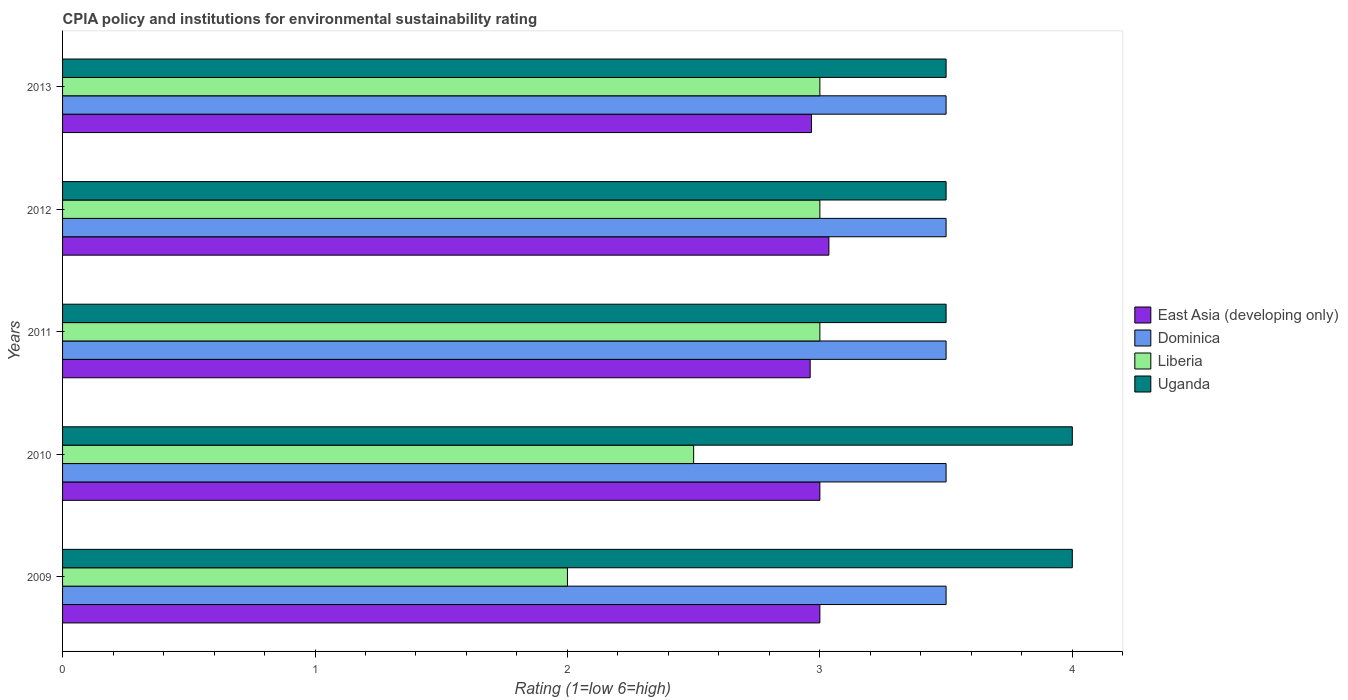How many different coloured bars are there?
Make the answer very short. 4. How many bars are there on the 1st tick from the bottom?
Your answer should be compact. 4. What is the label of the 1st group of bars from the top?
Your response must be concise. 2013. In how many cases, is the number of bars for a given year not equal to the number of legend labels?
Make the answer very short. 0. In which year was the CPIA rating in East Asia (developing only) maximum?
Offer a terse response. 2012. In which year was the CPIA rating in Uganda minimum?
Your answer should be compact. 2011. What is the total CPIA rating in Dominica in the graph?
Offer a terse response. 17.5. What is the difference between the CPIA rating in East Asia (developing only) in 2009 and that in 2011?
Offer a terse response. 0.04. What is the difference between the CPIA rating in Uganda in 2011 and the CPIA rating in Liberia in 2012?
Provide a short and direct response. 0.5. What is the average CPIA rating in East Asia (developing only) per year?
Provide a short and direct response. 2.99. In the year 2011, what is the difference between the CPIA rating in East Asia (developing only) and CPIA rating in Dominica?
Provide a succinct answer. -0.54. What is the ratio of the CPIA rating in Liberia in 2012 to that in 2013?
Provide a succinct answer. 1. Is the CPIA rating in Dominica in 2011 less than that in 2012?
Offer a very short reply. No. What is the difference between the highest and the second highest CPIA rating in East Asia (developing only)?
Your answer should be compact. 0.04. In how many years, is the CPIA rating in East Asia (developing only) greater than the average CPIA rating in East Asia (developing only) taken over all years?
Give a very brief answer. 3. Is the sum of the CPIA rating in East Asia (developing only) in 2010 and 2011 greater than the maximum CPIA rating in Uganda across all years?
Offer a very short reply. Yes. What does the 1st bar from the top in 2011 represents?
Provide a short and direct response. Uganda. What does the 2nd bar from the bottom in 2010 represents?
Your answer should be compact. Dominica. How many bars are there?
Ensure brevity in your answer.  20. Are all the bars in the graph horizontal?
Your answer should be very brief. Yes. How many years are there in the graph?
Offer a very short reply. 5. What is the difference between two consecutive major ticks on the X-axis?
Keep it short and to the point. 1. Are the values on the major ticks of X-axis written in scientific E-notation?
Give a very brief answer. No. Does the graph contain any zero values?
Make the answer very short. No. How many legend labels are there?
Provide a short and direct response. 4. What is the title of the graph?
Your response must be concise. CPIA policy and institutions for environmental sustainability rating. Does "Oman" appear as one of the legend labels in the graph?
Your answer should be compact. No. What is the label or title of the X-axis?
Offer a terse response. Rating (1=low 6=high). What is the Rating (1=low 6=high) in East Asia (developing only) in 2009?
Keep it short and to the point. 3. What is the Rating (1=low 6=high) in Dominica in 2009?
Ensure brevity in your answer.  3.5. What is the Rating (1=low 6=high) of Uganda in 2010?
Offer a terse response. 4. What is the Rating (1=low 6=high) of East Asia (developing only) in 2011?
Provide a succinct answer. 2.96. What is the Rating (1=low 6=high) in Liberia in 2011?
Your response must be concise. 3. What is the Rating (1=low 6=high) in East Asia (developing only) in 2012?
Your response must be concise. 3.04. What is the Rating (1=low 6=high) in Dominica in 2012?
Offer a very short reply. 3.5. What is the Rating (1=low 6=high) of Uganda in 2012?
Ensure brevity in your answer.  3.5. What is the Rating (1=low 6=high) of East Asia (developing only) in 2013?
Your answer should be compact. 2.97. What is the Rating (1=low 6=high) of Dominica in 2013?
Offer a terse response. 3.5. What is the Rating (1=low 6=high) of Uganda in 2013?
Your answer should be very brief. 3.5. Across all years, what is the maximum Rating (1=low 6=high) in East Asia (developing only)?
Keep it short and to the point. 3.04. Across all years, what is the maximum Rating (1=low 6=high) of Uganda?
Offer a terse response. 4. Across all years, what is the minimum Rating (1=low 6=high) in East Asia (developing only)?
Offer a very short reply. 2.96. Across all years, what is the minimum Rating (1=low 6=high) of Liberia?
Your answer should be very brief. 2. Across all years, what is the minimum Rating (1=low 6=high) of Uganda?
Make the answer very short. 3.5. What is the total Rating (1=low 6=high) in East Asia (developing only) in the graph?
Your answer should be compact. 14.96. What is the total Rating (1=low 6=high) in Dominica in the graph?
Provide a short and direct response. 17.5. What is the total Rating (1=low 6=high) in Liberia in the graph?
Offer a terse response. 13.5. What is the total Rating (1=low 6=high) in Uganda in the graph?
Your answer should be compact. 18.5. What is the difference between the Rating (1=low 6=high) of East Asia (developing only) in 2009 and that in 2010?
Provide a short and direct response. 0. What is the difference between the Rating (1=low 6=high) of Dominica in 2009 and that in 2010?
Offer a very short reply. 0. What is the difference between the Rating (1=low 6=high) of Liberia in 2009 and that in 2010?
Provide a short and direct response. -0.5. What is the difference between the Rating (1=low 6=high) in Uganda in 2009 and that in 2010?
Provide a short and direct response. 0. What is the difference between the Rating (1=low 6=high) in East Asia (developing only) in 2009 and that in 2011?
Your answer should be compact. 0.04. What is the difference between the Rating (1=low 6=high) in Liberia in 2009 and that in 2011?
Your answer should be very brief. -1. What is the difference between the Rating (1=low 6=high) of East Asia (developing only) in 2009 and that in 2012?
Offer a terse response. -0.04. What is the difference between the Rating (1=low 6=high) of Dominica in 2009 and that in 2012?
Keep it short and to the point. 0. What is the difference between the Rating (1=low 6=high) in Uganda in 2009 and that in 2012?
Provide a short and direct response. 0.5. What is the difference between the Rating (1=low 6=high) in East Asia (developing only) in 2009 and that in 2013?
Ensure brevity in your answer.  0.03. What is the difference between the Rating (1=low 6=high) in Liberia in 2009 and that in 2013?
Your response must be concise. -1. What is the difference between the Rating (1=low 6=high) of Uganda in 2009 and that in 2013?
Keep it short and to the point. 0.5. What is the difference between the Rating (1=low 6=high) of East Asia (developing only) in 2010 and that in 2011?
Your answer should be compact. 0.04. What is the difference between the Rating (1=low 6=high) in East Asia (developing only) in 2010 and that in 2012?
Give a very brief answer. -0.04. What is the difference between the Rating (1=low 6=high) in East Asia (developing only) in 2010 and that in 2013?
Offer a terse response. 0.03. What is the difference between the Rating (1=low 6=high) of Dominica in 2010 and that in 2013?
Ensure brevity in your answer.  0. What is the difference between the Rating (1=low 6=high) of East Asia (developing only) in 2011 and that in 2012?
Ensure brevity in your answer.  -0.07. What is the difference between the Rating (1=low 6=high) in Dominica in 2011 and that in 2012?
Offer a terse response. 0. What is the difference between the Rating (1=low 6=high) of Uganda in 2011 and that in 2012?
Ensure brevity in your answer.  0. What is the difference between the Rating (1=low 6=high) of East Asia (developing only) in 2011 and that in 2013?
Offer a very short reply. -0.01. What is the difference between the Rating (1=low 6=high) in Uganda in 2011 and that in 2013?
Offer a terse response. 0. What is the difference between the Rating (1=low 6=high) of East Asia (developing only) in 2012 and that in 2013?
Your answer should be compact. 0.07. What is the difference between the Rating (1=low 6=high) in Dominica in 2012 and that in 2013?
Offer a very short reply. 0. What is the difference between the Rating (1=low 6=high) in Liberia in 2012 and that in 2013?
Keep it short and to the point. 0. What is the difference between the Rating (1=low 6=high) in Uganda in 2012 and that in 2013?
Your answer should be compact. 0. What is the difference between the Rating (1=low 6=high) of East Asia (developing only) in 2009 and the Rating (1=low 6=high) of Uganda in 2010?
Keep it short and to the point. -1. What is the difference between the Rating (1=low 6=high) in East Asia (developing only) in 2009 and the Rating (1=low 6=high) in Liberia in 2011?
Your answer should be very brief. 0. What is the difference between the Rating (1=low 6=high) of East Asia (developing only) in 2009 and the Rating (1=low 6=high) of Uganda in 2011?
Provide a short and direct response. -0.5. What is the difference between the Rating (1=low 6=high) in Dominica in 2009 and the Rating (1=low 6=high) in Liberia in 2011?
Your answer should be compact. 0.5. What is the difference between the Rating (1=low 6=high) of Dominica in 2009 and the Rating (1=low 6=high) of Uganda in 2011?
Give a very brief answer. 0. What is the difference between the Rating (1=low 6=high) in Liberia in 2009 and the Rating (1=low 6=high) in Uganda in 2011?
Your answer should be very brief. -1.5. What is the difference between the Rating (1=low 6=high) of East Asia (developing only) in 2009 and the Rating (1=low 6=high) of Dominica in 2012?
Provide a short and direct response. -0.5. What is the difference between the Rating (1=low 6=high) in East Asia (developing only) in 2009 and the Rating (1=low 6=high) in Liberia in 2012?
Make the answer very short. 0. What is the difference between the Rating (1=low 6=high) in East Asia (developing only) in 2009 and the Rating (1=low 6=high) in Dominica in 2013?
Your answer should be very brief. -0.5. What is the difference between the Rating (1=low 6=high) in East Asia (developing only) in 2009 and the Rating (1=low 6=high) in Liberia in 2013?
Offer a very short reply. 0. What is the difference between the Rating (1=low 6=high) of East Asia (developing only) in 2009 and the Rating (1=low 6=high) of Uganda in 2013?
Make the answer very short. -0.5. What is the difference between the Rating (1=low 6=high) in Dominica in 2009 and the Rating (1=low 6=high) in Uganda in 2013?
Provide a succinct answer. 0. What is the difference between the Rating (1=low 6=high) in East Asia (developing only) in 2010 and the Rating (1=low 6=high) in Dominica in 2011?
Provide a succinct answer. -0.5. What is the difference between the Rating (1=low 6=high) of East Asia (developing only) in 2010 and the Rating (1=low 6=high) of Liberia in 2011?
Make the answer very short. 0. What is the difference between the Rating (1=low 6=high) of East Asia (developing only) in 2010 and the Rating (1=low 6=high) of Uganda in 2011?
Your answer should be compact. -0.5. What is the difference between the Rating (1=low 6=high) in Dominica in 2010 and the Rating (1=low 6=high) in Liberia in 2011?
Provide a short and direct response. 0.5. What is the difference between the Rating (1=low 6=high) in Dominica in 2010 and the Rating (1=low 6=high) in Uganda in 2011?
Give a very brief answer. 0. What is the difference between the Rating (1=low 6=high) in East Asia (developing only) in 2010 and the Rating (1=low 6=high) in Dominica in 2012?
Ensure brevity in your answer.  -0.5. What is the difference between the Rating (1=low 6=high) in East Asia (developing only) in 2010 and the Rating (1=low 6=high) in Liberia in 2012?
Keep it short and to the point. 0. What is the difference between the Rating (1=low 6=high) of East Asia (developing only) in 2010 and the Rating (1=low 6=high) of Uganda in 2012?
Provide a short and direct response. -0.5. What is the difference between the Rating (1=low 6=high) in Dominica in 2010 and the Rating (1=low 6=high) in Liberia in 2012?
Keep it short and to the point. 0.5. What is the difference between the Rating (1=low 6=high) of Dominica in 2010 and the Rating (1=low 6=high) of Uganda in 2012?
Provide a succinct answer. 0. What is the difference between the Rating (1=low 6=high) of Liberia in 2010 and the Rating (1=low 6=high) of Uganda in 2012?
Offer a very short reply. -1. What is the difference between the Rating (1=low 6=high) in East Asia (developing only) in 2010 and the Rating (1=low 6=high) in Dominica in 2013?
Provide a short and direct response. -0.5. What is the difference between the Rating (1=low 6=high) of East Asia (developing only) in 2010 and the Rating (1=low 6=high) of Liberia in 2013?
Offer a terse response. 0. What is the difference between the Rating (1=low 6=high) of East Asia (developing only) in 2010 and the Rating (1=low 6=high) of Uganda in 2013?
Offer a terse response. -0.5. What is the difference between the Rating (1=low 6=high) in East Asia (developing only) in 2011 and the Rating (1=low 6=high) in Dominica in 2012?
Provide a short and direct response. -0.54. What is the difference between the Rating (1=low 6=high) in East Asia (developing only) in 2011 and the Rating (1=low 6=high) in Liberia in 2012?
Make the answer very short. -0.04. What is the difference between the Rating (1=low 6=high) in East Asia (developing only) in 2011 and the Rating (1=low 6=high) in Uganda in 2012?
Offer a terse response. -0.54. What is the difference between the Rating (1=low 6=high) in Dominica in 2011 and the Rating (1=low 6=high) in Liberia in 2012?
Make the answer very short. 0.5. What is the difference between the Rating (1=low 6=high) in East Asia (developing only) in 2011 and the Rating (1=low 6=high) in Dominica in 2013?
Your answer should be very brief. -0.54. What is the difference between the Rating (1=low 6=high) in East Asia (developing only) in 2011 and the Rating (1=low 6=high) in Liberia in 2013?
Ensure brevity in your answer.  -0.04. What is the difference between the Rating (1=low 6=high) in East Asia (developing only) in 2011 and the Rating (1=low 6=high) in Uganda in 2013?
Offer a terse response. -0.54. What is the difference between the Rating (1=low 6=high) in Dominica in 2011 and the Rating (1=low 6=high) in Uganda in 2013?
Give a very brief answer. 0. What is the difference between the Rating (1=low 6=high) in East Asia (developing only) in 2012 and the Rating (1=low 6=high) in Dominica in 2013?
Provide a short and direct response. -0.46. What is the difference between the Rating (1=low 6=high) in East Asia (developing only) in 2012 and the Rating (1=low 6=high) in Liberia in 2013?
Provide a short and direct response. 0.04. What is the difference between the Rating (1=low 6=high) of East Asia (developing only) in 2012 and the Rating (1=low 6=high) of Uganda in 2013?
Offer a terse response. -0.46. What is the difference between the Rating (1=low 6=high) in Dominica in 2012 and the Rating (1=low 6=high) in Uganda in 2013?
Offer a very short reply. 0. What is the difference between the Rating (1=low 6=high) of Liberia in 2012 and the Rating (1=low 6=high) of Uganda in 2013?
Your response must be concise. -0.5. What is the average Rating (1=low 6=high) in East Asia (developing only) per year?
Your response must be concise. 2.99. What is the average Rating (1=low 6=high) of Dominica per year?
Keep it short and to the point. 3.5. What is the average Rating (1=low 6=high) of Liberia per year?
Your response must be concise. 2.7. In the year 2009, what is the difference between the Rating (1=low 6=high) of East Asia (developing only) and Rating (1=low 6=high) of Dominica?
Your answer should be compact. -0.5. In the year 2009, what is the difference between the Rating (1=low 6=high) of East Asia (developing only) and Rating (1=low 6=high) of Liberia?
Provide a short and direct response. 1. In the year 2009, what is the difference between the Rating (1=low 6=high) of Dominica and Rating (1=low 6=high) of Liberia?
Your answer should be very brief. 1.5. In the year 2009, what is the difference between the Rating (1=low 6=high) in Liberia and Rating (1=low 6=high) in Uganda?
Your answer should be very brief. -2. In the year 2010, what is the difference between the Rating (1=low 6=high) of East Asia (developing only) and Rating (1=low 6=high) of Uganda?
Give a very brief answer. -1. In the year 2011, what is the difference between the Rating (1=low 6=high) of East Asia (developing only) and Rating (1=low 6=high) of Dominica?
Provide a succinct answer. -0.54. In the year 2011, what is the difference between the Rating (1=low 6=high) in East Asia (developing only) and Rating (1=low 6=high) in Liberia?
Your response must be concise. -0.04. In the year 2011, what is the difference between the Rating (1=low 6=high) in East Asia (developing only) and Rating (1=low 6=high) in Uganda?
Your response must be concise. -0.54. In the year 2011, what is the difference between the Rating (1=low 6=high) in Liberia and Rating (1=low 6=high) in Uganda?
Your response must be concise. -0.5. In the year 2012, what is the difference between the Rating (1=low 6=high) of East Asia (developing only) and Rating (1=low 6=high) of Dominica?
Keep it short and to the point. -0.46. In the year 2012, what is the difference between the Rating (1=low 6=high) of East Asia (developing only) and Rating (1=low 6=high) of Liberia?
Make the answer very short. 0.04. In the year 2012, what is the difference between the Rating (1=low 6=high) of East Asia (developing only) and Rating (1=low 6=high) of Uganda?
Make the answer very short. -0.46. In the year 2012, what is the difference between the Rating (1=low 6=high) of Dominica and Rating (1=low 6=high) of Liberia?
Offer a very short reply. 0.5. In the year 2012, what is the difference between the Rating (1=low 6=high) in Dominica and Rating (1=low 6=high) in Uganda?
Make the answer very short. 0. In the year 2013, what is the difference between the Rating (1=low 6=high) in East Asia (developing only) and Rating (1=low 6=high) in Dominica?
Keep it short and to the point. -0.53. In the year 2013, what is the difference between the Rating (1=low 6=high) in East Asia (developing only) and Rating (1=low 6=high) in Liberia?
Offer a very short reply. -0.03. In the year 2013, what is the difference between the Rating (1=low 6=high) of East Asia (developing only) and Rating (1=low 6=high) of Uganda?
Offer a terse response. -0.53. In the year 2013, what is the difference between the Rating (1=low 6=high) in Dominica and Rating (1=low 6=high) in Liberia?
Your answer should be very brief. 0.5. In the year 2013, what is the difference between the Rating (1=low 6=high) in Liberia and Rating (1=low 6=high) in Uganda?
Your answer should be compact. -0.5. What is the ratio of the Rating (1=low 6=high) in East Asia (developing only) in 2009 to that in 2010?
Provide a succinct answer. 1. What is the ratio of the Rating (1=low 6=high) of Liberia in 2009 to that in 2010?
Give a very brief answer. 0.8. What is the ratio of the Rating (1=low 6=high) of Dominica in 2009 to that in 2011?
Your response must be concise. 1. What is the ratio of the Rating (1=low 6=high) in Uganda in 2009 to that in 2011?
Keep it short and to the point. 1.14. What is the ratio of the Rating (1=low 6=high) in East Asia (developing only) in 2009 to that in 2012?
Offer a terse response. 0.99. What is the ratio of the Rating (1=low 6=high) in Dominica in 2009 to that in 2012?
Your response must be concise. 1. What is the ratio of the Rating (1=low 6=high) of Uganda in 2009 to that in 2012?
Make the answer very short. 1.14. What is the ratio of the Rating (1=low 6=high) of East Asia (developing only) in 2009 to that in 2013?
Provide a short and direct response. 1.01. What is the ratio of the Rating (1=low 6=high) of Dominica in 2009 to that in 2013?
Offer a terse response. 1. What is the ratio of the Rating (1=low 6=high) of Liberia in 2009 to that in 2013?
Ensure brevity in your answer.  0.67. What is the ratio of the Rating (1=low 6=high) of Uganda in 2009 to that in 2013?
Offer a very short reply. 1.14. What is the ratio of the Rating (1=low 6=high) of East Asia (developing only) in 2010 to that in 2011?
Your response must be concise. 1.01. What is the ratio of the Rating (1=low 6=high) of Liberia in 2010 to that in 2011?
Give a very brief answer. 0.83. What is the ratio of the Rating (1=low 6=high) in East Asia (developing only) in 2010 to that in 2012?
Make the answer very short. 0.99. What is the ratio of the Rating (1=low 6=high) in Dominica in 2010 to that in 2012?
Keep it short and to the point. 1. What is the ratio of the Rating (1=low 6=high) of Uganda in 2010 to that in 2012?
Your response must be concise. 1.14. What is the ratio of the Rating (1=low 6=high) of East Asia (developing only) in 2010 to that in 2013?
Give a very brief answer. 1.01. What is the ratio of the Rating (1=low 6=high) of East Asia (developing only) in 2011 to that in 2012?
Provide a short and direct response. 0.98. What is the ratio of the Rating (1=low 6=high) of Liberia in 2011 to that in 2012?
Your answer should be very brief. 1. What is the ratio of the Rating (1=low 6=high) in Uganda in 2011 to that in 2012?
Keep it short and to the point. 1. What is the ratio of the Rating (1=low 6=high) of Liberia in 2011 to that in 2013?
Provide a short and direct response. 1. What is the ratio of the Rating (1=low 6=high) in East Asia (developing only) in 2012 to that in 2013?
Make the answer very short. 1.02. What is the ratio of the Rating (1=low 6=high) of Dominica in 2012 to that in 2013?
Ensure brevity in your answer.  1. What is the ratio of the Rating (1=low 6=high) in Liberia in 2012 to that in 2013?
Offer a terse response. 1. What is the difference between the highest and the second highest Rating (1=low 6=high) of East Asia (developing only)?
Your response must be concise. 0.04. What is the difference between the highest and the second highest Rating (1=low 6=high) in Dominica?
Provide a short and direct response. 0. What is the difference between the highest and the second highest Rating (1=low 6=high) in Liberia?
Your answer should be very brief. 0. What is the difference between the highest and the lowest Rating (1=low 6=high) of East Asia (developing only)?
Keep it short and to the point. 0.07. What is the difference between the highest and the lowest Rating (1=low 6=high) of Dominica?
Provide a short and direct response. 0. What is the difference between the highest and the lowest Rating (1=low 6=high) in Liberia?
Keep it short and to the point. 1. What is the difference between the highest and the lowest Rating (1=low 6=high) in Uganda?
Keep it short and to the point. 0.5. 